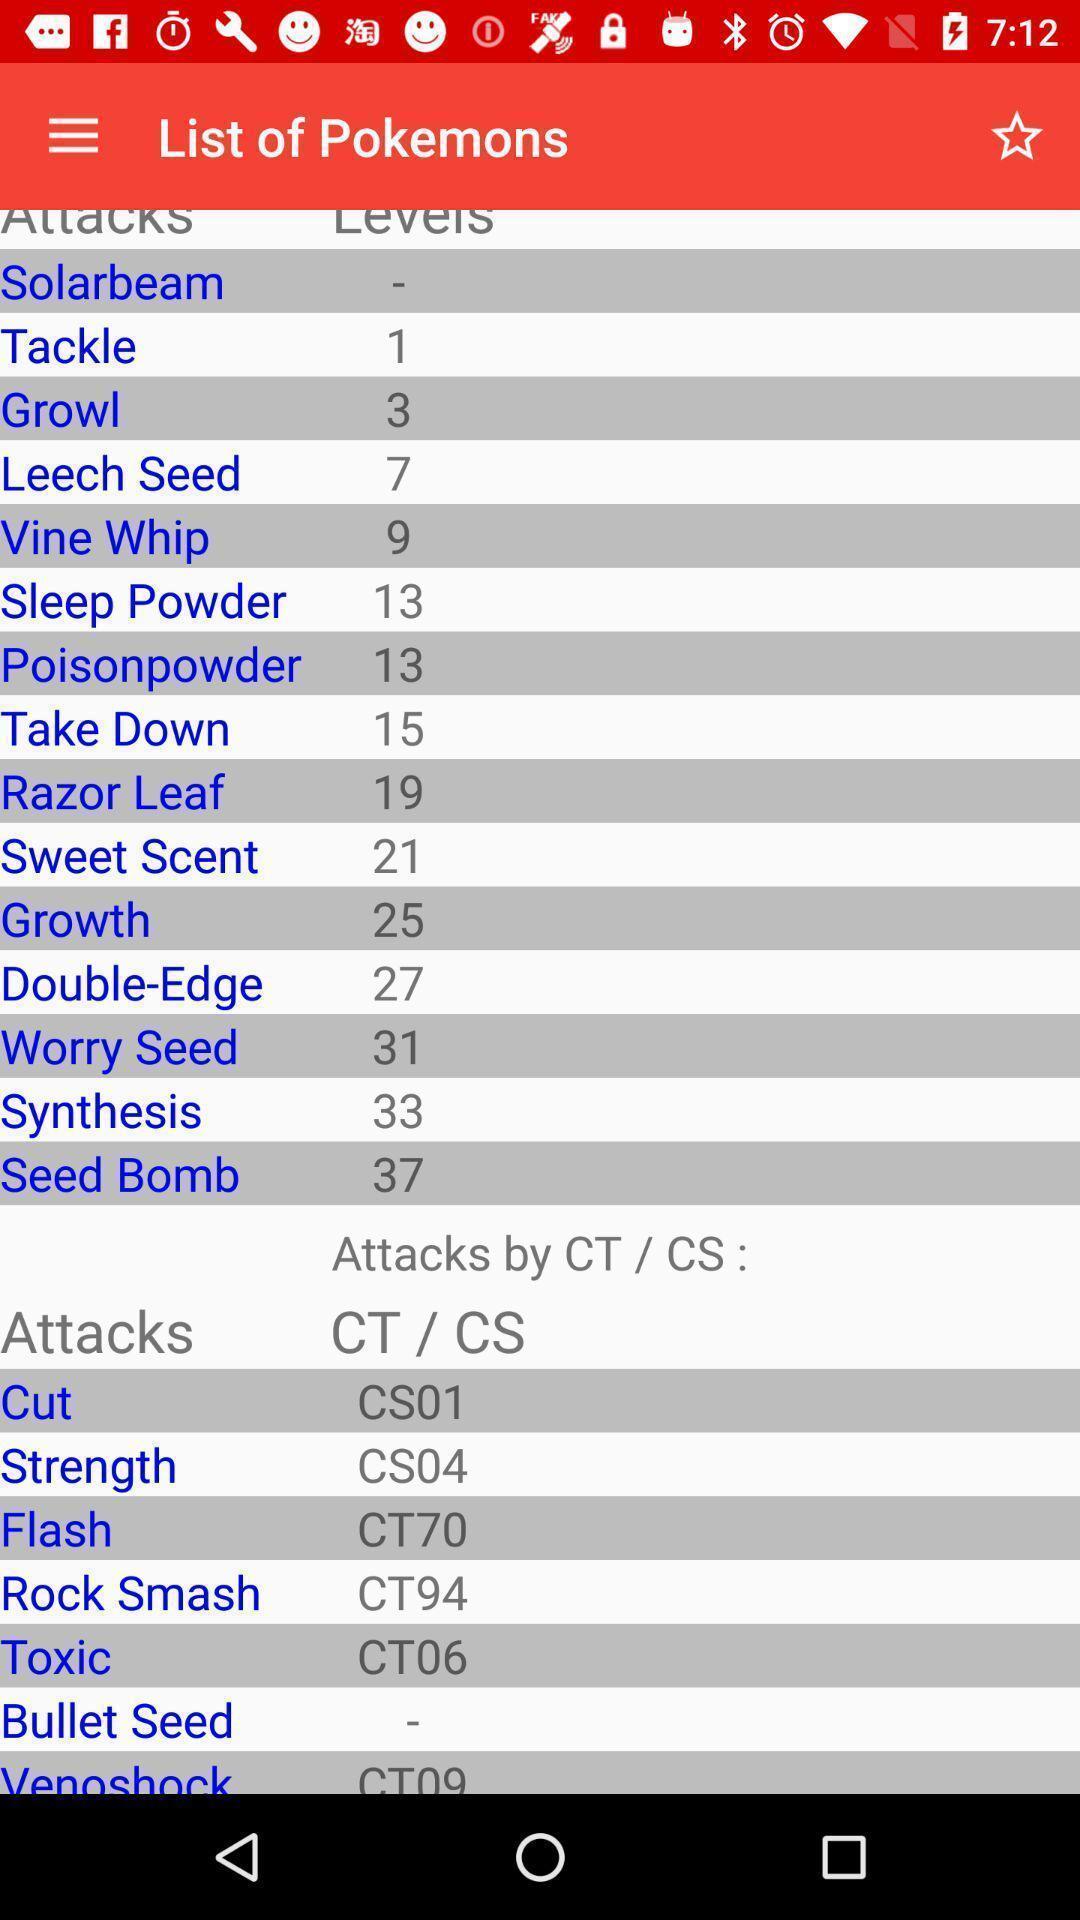Provide a textual representation of this image. Screen displaying a list of names. 